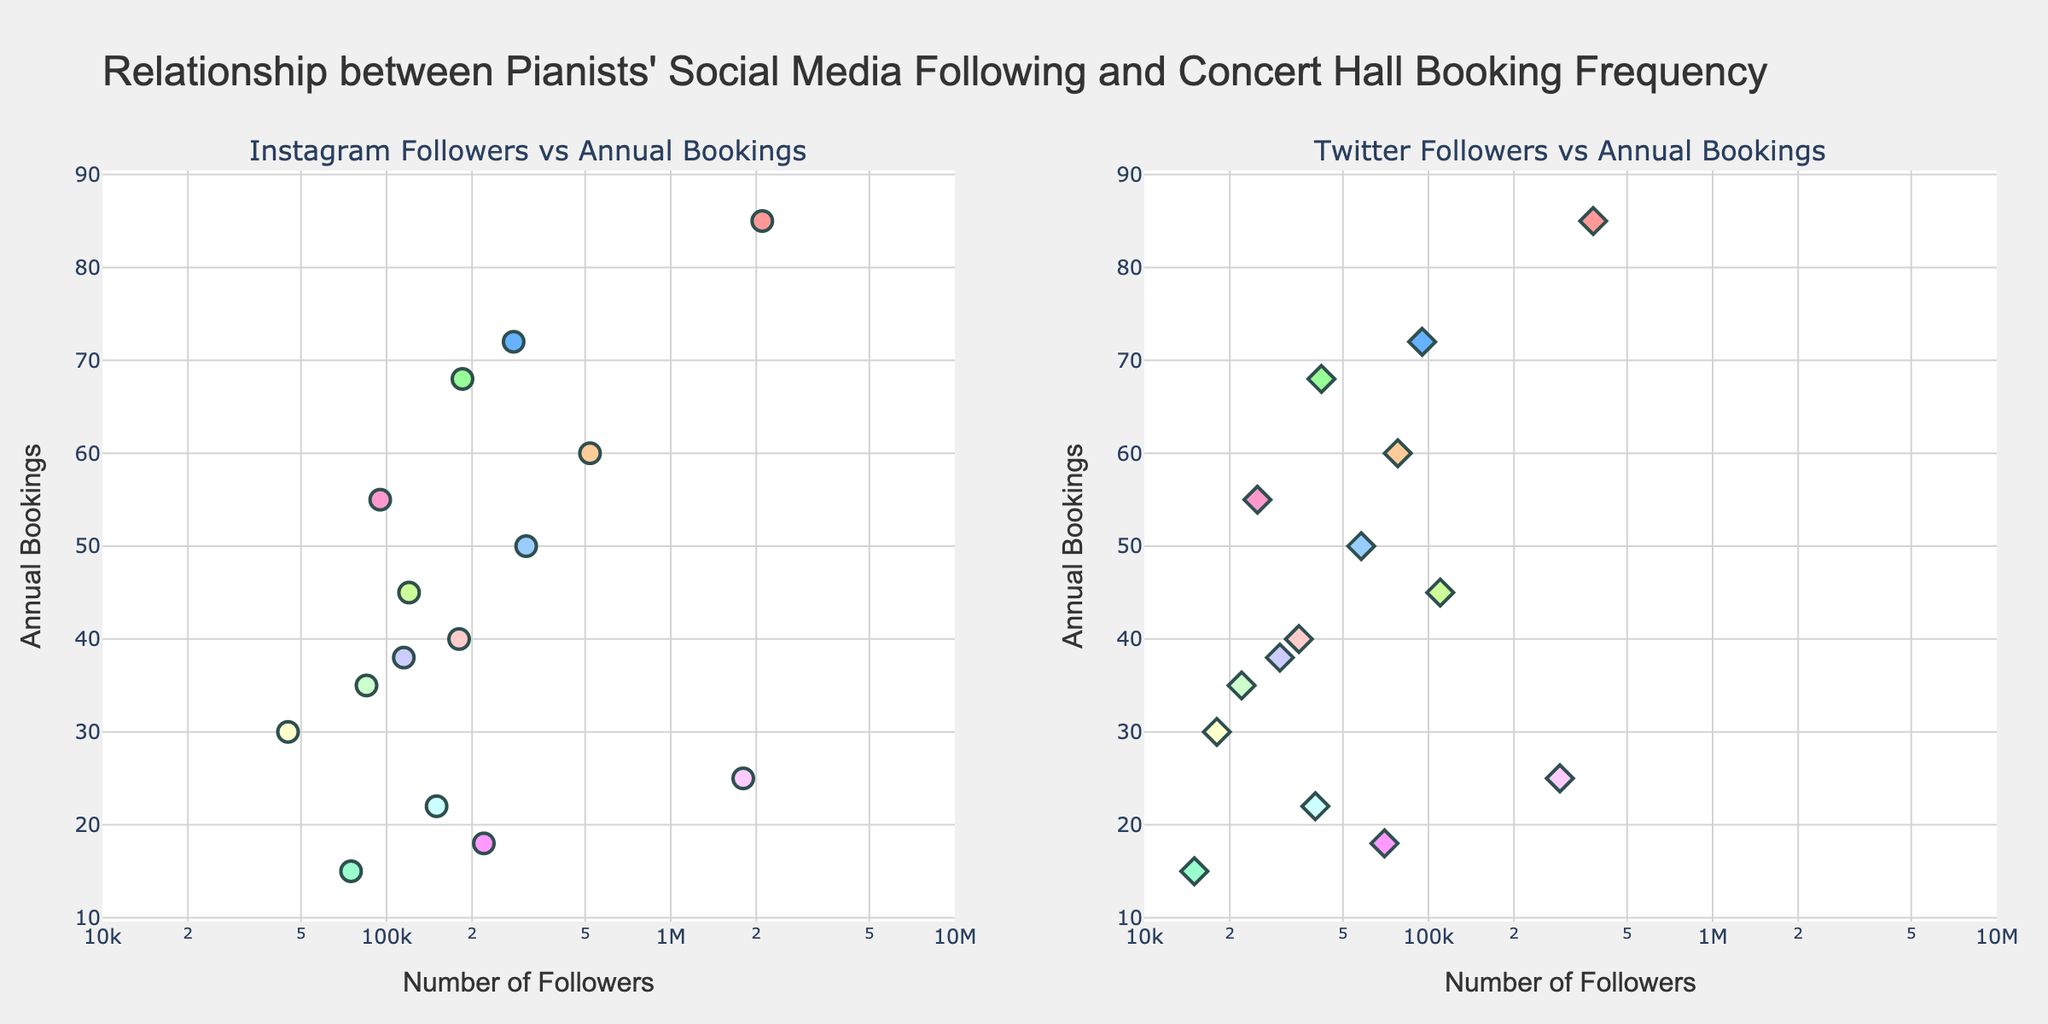what is the relationship between Instagram followers and annual bookings for the pianists? The title and the scatter plot on the left side indicate that the x-axis represents the number of Instagram followers, while the y-axis represents the annual bookings for each pianist. The scatter plot suggests a positive correlation, where pianists with more Instagram followers tend to have more annual bookings.
Answer: Positive correlation how many data points are shown in each scatter plot? There are 15 pianists listed in the data provided. Since the scatter plot includes all of them, each plot contains 15 data points.
Answer: 15 which pianist has the highest number of Instagram followers and how many bookings do they have? The scatter plot shows Lang Lang as the pianist with the highest number of Instagram followers, which is 2,100,000. Referring to the y-axis, Lang Lang has 85 annual bookings.
Answer: Lang Lang, 85 bookings who has more annual bookings, Yuja Wang or Daniil Trifonov? By locating the data points for Yuja Wang and Daniil Trifonov on the scatter plot, Yuja Wang has 72 annual bookings, and Daniil Trifonov has 68. Yuja Wang has more annual bookings.
Answer: Yuja Wang how many followers does the pianist with the fewest annual bookings have on both Instagram and Twitter? The pianist with the fewest annual bookings is Mao Fujita with 15 bookings. By identifying his data points on both scatter plots, Mao Fujita has 75,000 Instagram followers and 15,000 Twitter followers.
Answer: Instagram: 75,000, Twitter: 15,000 is there a pianist who has a high Instagram following but relatively low annual bookings? Yundi Li has 1,800,000 Instagram followers but only 25 annual bookings, which is relatively low compared to his follower count.
Answer: Yundi Li find the difference in annual bookings between the pianist with the most Instagram followers and the one with the most Twitter followers Lang Lang has the highest number of Instagram followers (2,100,000) with 85 bookings. Khatia Buniatishvili, who has one of the top Twitter followers (78,000), has 60 bookings. The difference in their annual bookings is 85 - 60 = 25.
Answer: 25 how many pianists have more than 500,000 Instagram followers? By counting the relevant points in the left scatter plot, two pianists have more than 500,000 Instagram followers: Lang Lang and Khatia Buniatishvili.
Answer: 2 